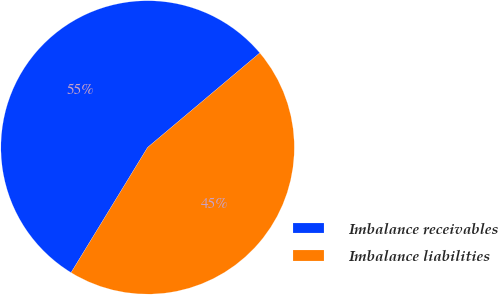Convert chart. <chart><loc_0><loc_0><loc_500><loc_500><pie_chart><fcel>Imbalance receivables<fcel>Imbalance liabilities<nl><fcel>55.13%<fcel>44.87%<nl></chart> 